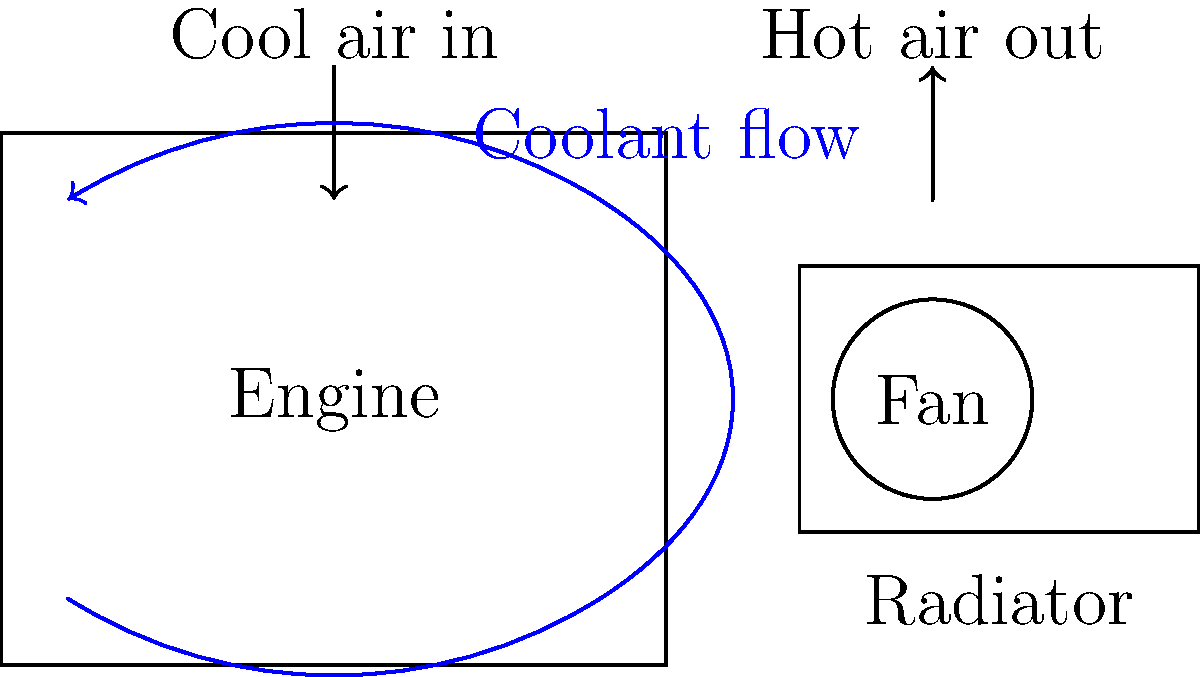In the schematic of a tour bus engine's cooling system, what component is responsible for forcing air through the radiator to enhance heat dissipation? To answer this question, let's break down the components and their functions in the cooling system:

1. Engine: This is where heat is generated during the combustion process.
2. Coolant: The blue arrows represent the flow of coolant, which absorbs heat from the engine.
3. Radiator: This component is designed to dissipate heat from the coolant to the surrounding air.
4. Fan: Located behind the radiator, this component is crucial for forced air convection.
5. Airflow: The arrows above the system show cool air entering and hot air exiting.

The key to enhancing heat dissipation in this system is forcing air through the radiator. While the motion of the tour bus can provide some airflow (ram air effect), it's not always sufficient, especially when the bus is idling or moving slowly.

The component responsible for ensuring consistent airflow through the radiator, regardless of the bus's speed, is the fan. It creates a forced convection effect, drawing cool air through the radiator fins and expelling hot air, thus significantly improving the cooling system's efficiency.
Answer: Fan 